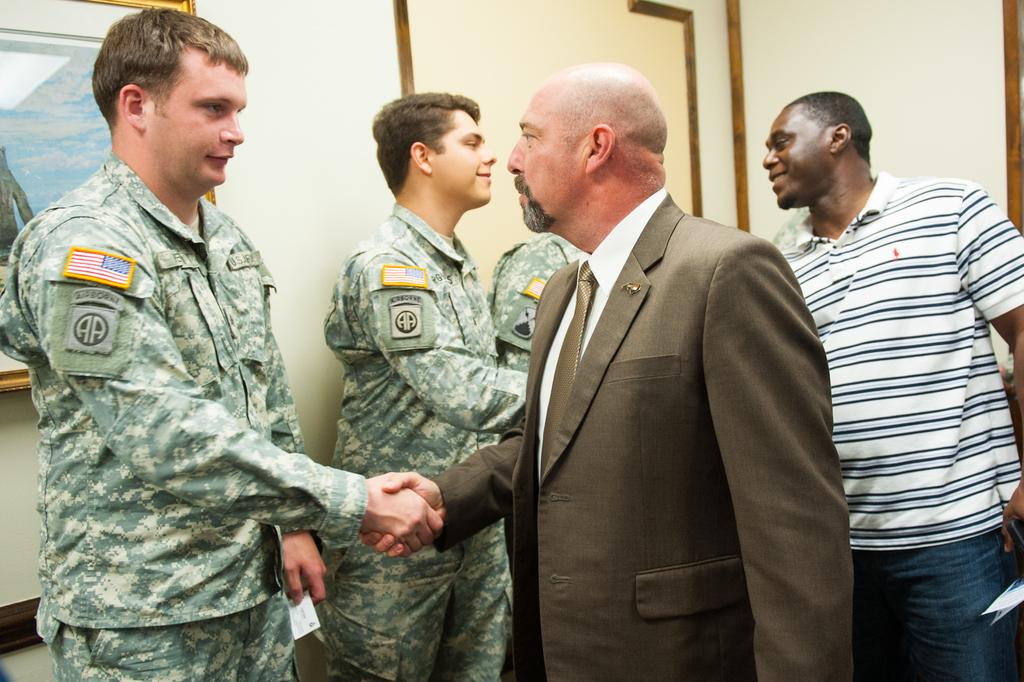What are the men in the image doing? The men are standing and shaking hands in the image. How are the men interacting with each other? The men are looking at each other while shaking hands. What can be seen in the background of the image? There is a wall in the background of the image. Is there any additional feature attached to the wall? Yes, a frame is attached to the wall. What is the price of the rice in the image? There is no rice or price mentioned in the image. What type of stem is visible in the image? There is no stem present in the image. 